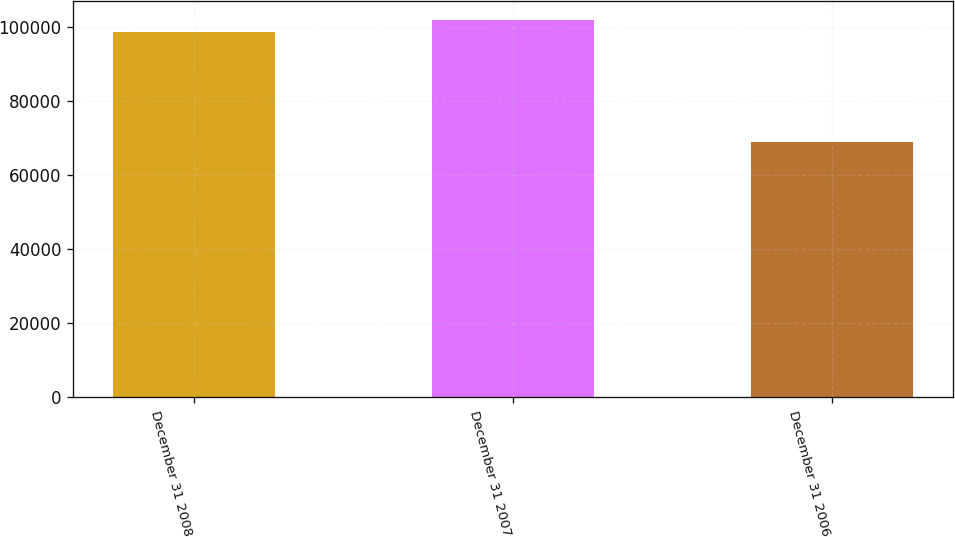<chart> <loc_0><loc_0><loc_500><loc_500><bar_chart><fcel>December 31 2008<fcel>December 31 2007<fcel>December 31 2006<nl><fcel>98629<fcel>101864<fcel>68911<nl></chart> 